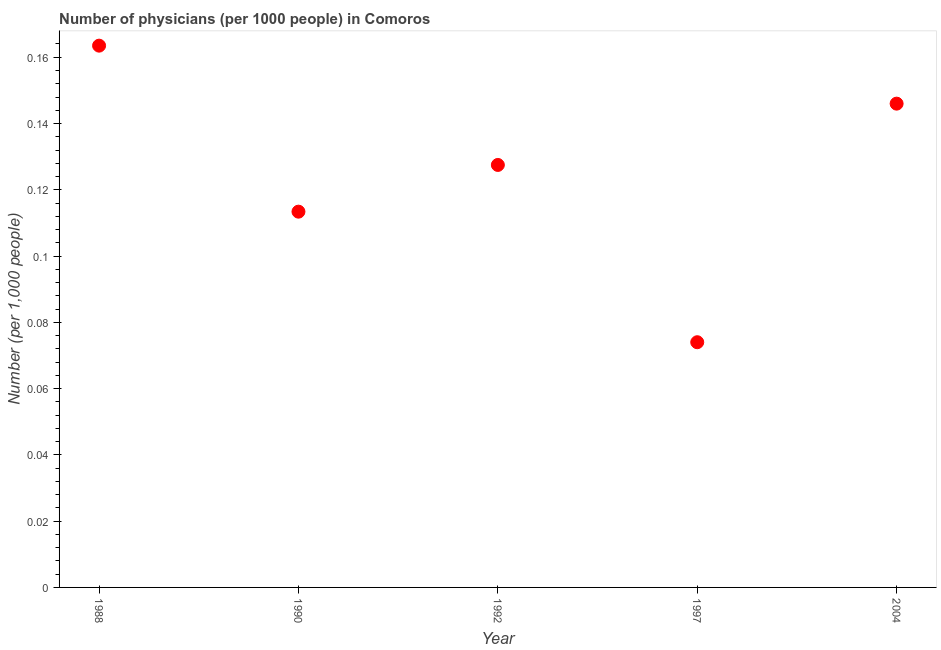What is the number of physicians in 1997?
Keep it short and to the point. 0.07. Across all years, what is the maximum number of physicians?
Provide a short and direct response. 0.16. Across all years, what is the minimum number of physicians?
Provide a short and direct response. 0.07. What is the sum of the number of physicians?
Offer a very short reply. 0.62. What is the difference between the number of physicians in 1992 and 1997?
Offer a terse response. 0.05. What is the average number of physicians per year?
Provide a short and direct response. 0.12. What is the median number of physicians?
Keep it short and to the point. 0.13. In how many years, is the number of physicians greater than 0.068 ?
Make the answer very short. 5. Do a majority of the years between 2004 and 1997 (inclusive) have number of physicians greater than 0.02 ?
Your response must be concise. No. What is the ratio of the number of physicians in 1988 to that in 1997?
Give a very brief answer. 2.21. What is the difference between the highest and the second highest number of physicians?
Ensure brevity in your answer.  0.02. Is the sum of the number of physicians in 1988 and 1992 greater than the maximum number of physicians across all years?
Offer a very short reply. Yes. What is the difference between the highest and the lowest number of physicians?
Give a very brief answer. 0.09. In how many years, is the number of physicians greater than the average number of physicians taken over all years?
Make the answer very short. 3. How many years are there in the graph?
Offer a terse response. 5. What is the difference between two consecutive major ticks on the Y-axis?
Offer a very short reply. 0.02. Are the values on the major ticks of Y-axis written in scientific E-notation?
Make the answer very short. No. Does the graph contain any zero values?
Provide a succinct answer. No. Does the graph contain grids?
Offer a very short reply. No. What is the title of the graph?
Keep it short and to the point. Number of physicians (per 1000 people) in Comoros. What is the label or title of the X-axis?
Offer a very short reply. Year. What is the label or title of the Y-axis?
Provide a short and direct response. Number (per 1,0 people). What is the Number (per 1,000 people) in 1988?
Provide a short and direct response. 0.16. What is the Number (per 1,000 people) in 1990?
Keep it short and to the point. 0.11. What is the Number (per 1,000 people) in 1992?
Your answer should be very brief. 0.13. What is the Number (per 1,000 people) in 1997?
Provide a succinct answer. 0.07. What is the Number (per 1,000 people) in 2004?
Provide a succinct answer. 0.15. What is the difference between the Number (per 1,000 people) in 1988 and 1990?
Your answer should be very brief. 0.05. What is the difference between the Number (per 1,000 people) in 1988 and 1992?
Make the answer very short. 0.04. What is the difference between the Number (per 1,000 people) in 1988 and 1997?
Your answer should be very brief. 0.09. What is the difference between the Number (per 1,000 people) in 1988 and 2004?
Your response must be concise. 0.02. What is the difference between the Number (per 1,000 people) in 1990 and 1992?
Keep it short and to the point. -0.01. What is the difference between the Number (per 1,000 people) in 1990 and 1997?
Provide a succinct answer. 0.04. What is the difference between the Number (per 1,000 people) in 1990 and 2004?
Offer a very short reply. -0.03. What is the difference between the Number (per 1,000 people) in 1992 and 1997?
Ensure brevity in your answer.  0.05. What is the difference between the Number (per 1,000 people) in 1992 and 2004?
Offer a terse response. -0.02. What is the difference between the Number (per 1,000 people) in 1997 and 2004?
Your answer should be compact. -0.07. What is the ratio of the Number (per 1,000 people) in 1988 to that in 1990?
Ensure brevity in your answer.  1.44. What is the ratio of the Number (per 1,000 people) in 1988 to that in 1992?
Keep it short and to the point. 1.28. What is the ratio of the Number (per 1,000 people) in 1988 to that in 1997?
Keep it short and to the point. 2.21. What is the ratio of the Number (per 1,000 people) in 1988 to that in 2004?
Provide a succinct answer. 1.12. What is the ratio of the Number (per 1,000 people) in 1990 to that in 1992?
Ensure brevity in your answer.  0.89. What is the ratio of the Number (per 1,000 people) in 1990 to that in 1997?
Ensure brevity in your answer.  1.53. What is the ratio of the Number (per 1,000 people) in 1990 to that in 2004?
Provide a succinct answer. 0.78. What is the ratio of the Number (per 1,000 people) in 1992 to that in 1997?
Your answer should be very brief. 1.72. What is the ratio of the Number (per 1,000 people) in 1992 to that in 2004?
Provide a short and direct response. 0.87. What is the ratio of the Number (per 1,000 people) in 1997 to that in 2004?
Give a very brief answer. 0.51. 